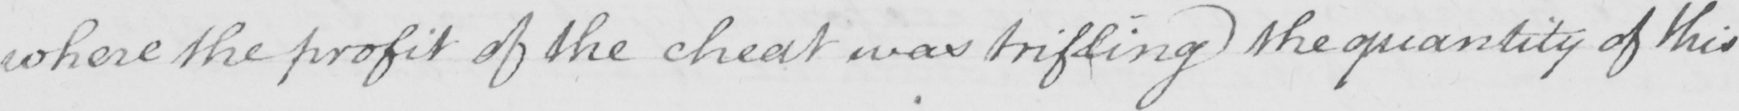Please transcribe the handwritten text in this image. where the profit of the cheat was trifling the quantity of this 